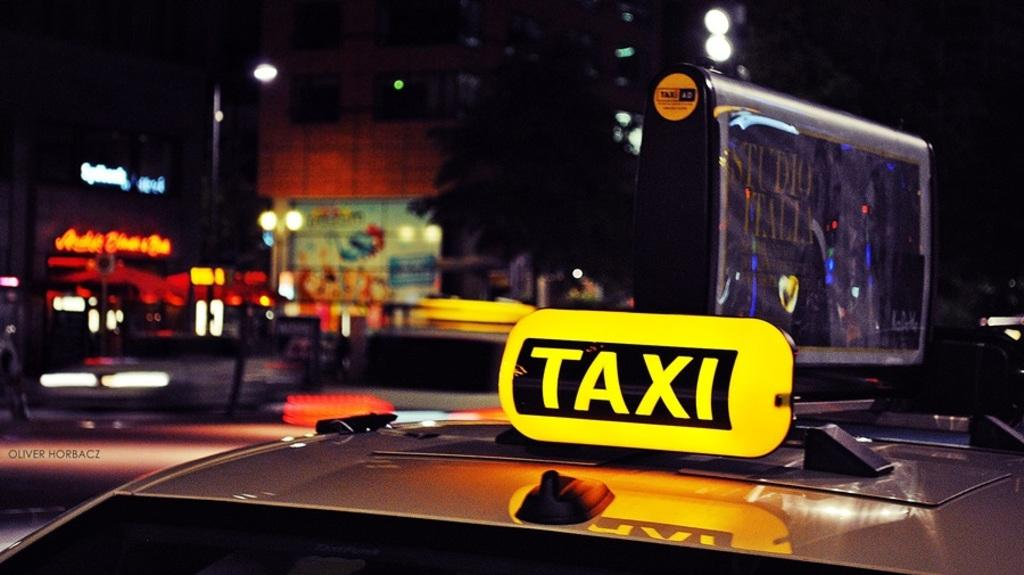Provide a one-sentence caption for the provided image. A vehicle with a TAXI sign placed on the car as it is outside in the city at night time. 